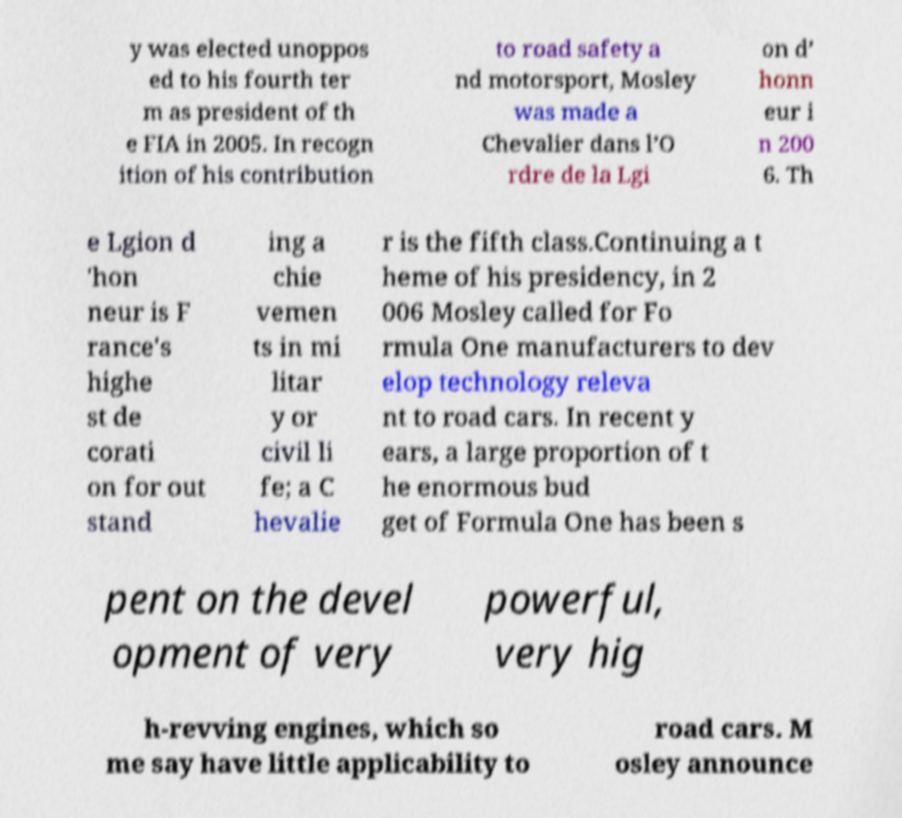There's text embedded in this image that I need extracted. Can you transcribe it verbatim? y was elected unoppos ed to his fourth ter m as president of th e FIA in 2005. In recogn ition of his contribution to road safety a nd motorsport, Mosley was made a Chevalier dans l’O rdre de la Lgi on d’ honn eur i n 200 6. Th e Lgion d 'hon neur is F rance's highe st de corati on for out stand ing a chie vemen ts in mi litar y or civil li fe; a C hevalie r is the fifth class.Continuing a t heme of his presidency, in 2 006 Mosley called for Fo rmula One manufacturers to dev elop technology releva nt to road cars. In recent y ears, a large proportion of t he enormous bud get of Formula One has been s pent on the devel opment of very powerful, very hig h-revving engines, which so me say have little applicability to road cars. M osley announce 